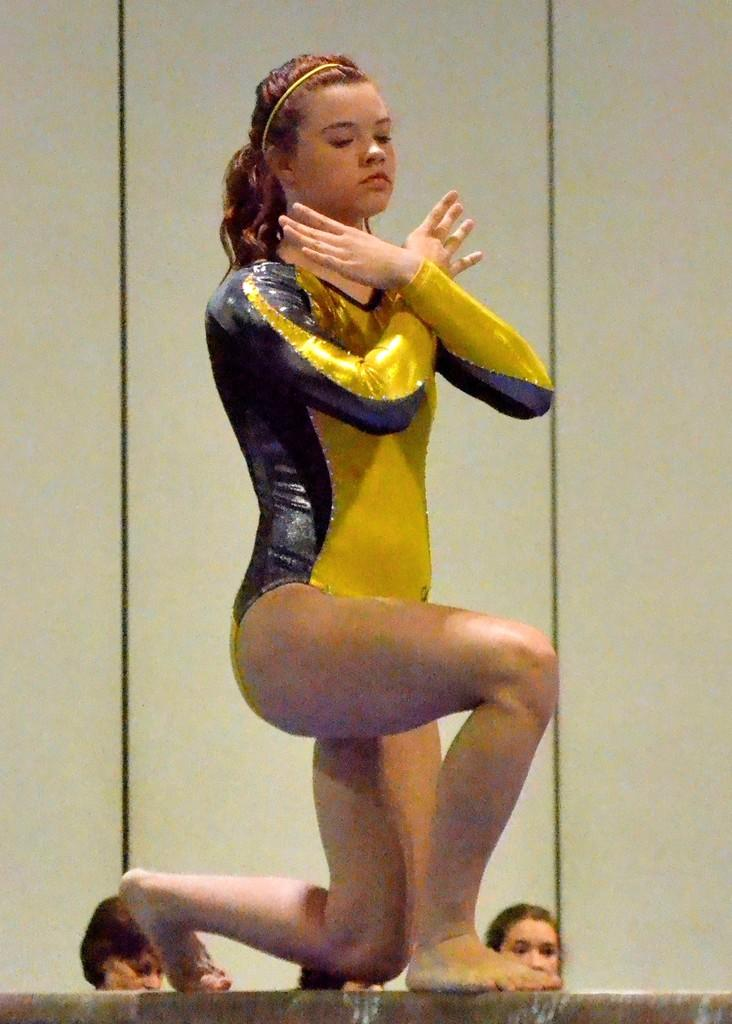What is the main subject of the image? There is a woman on a platform in the image. Are there any other people visible in the image? Yes, there are women in the background of the image. What can be seen in the background of the image? There is a wall visible in the background of the image. What type of twig is being used as a prop by the woman on the platform? There is no twig present in the image. How does the sand affect the stability of the platform in the image? There is no sand present in the image, so its effect on the platform's stability cannot be determined. 